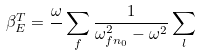<formula> <loc_0><loc_0><loc_500><loc_500>\beta _ { E } ^ { T } = \frac { \omega } { } \sum _ { f } \frac { 1 } { \omega _ { f n _ { 0 } } ^ { 2 } - \omega ^ { 2 } } \sum _ { l }</formula> 